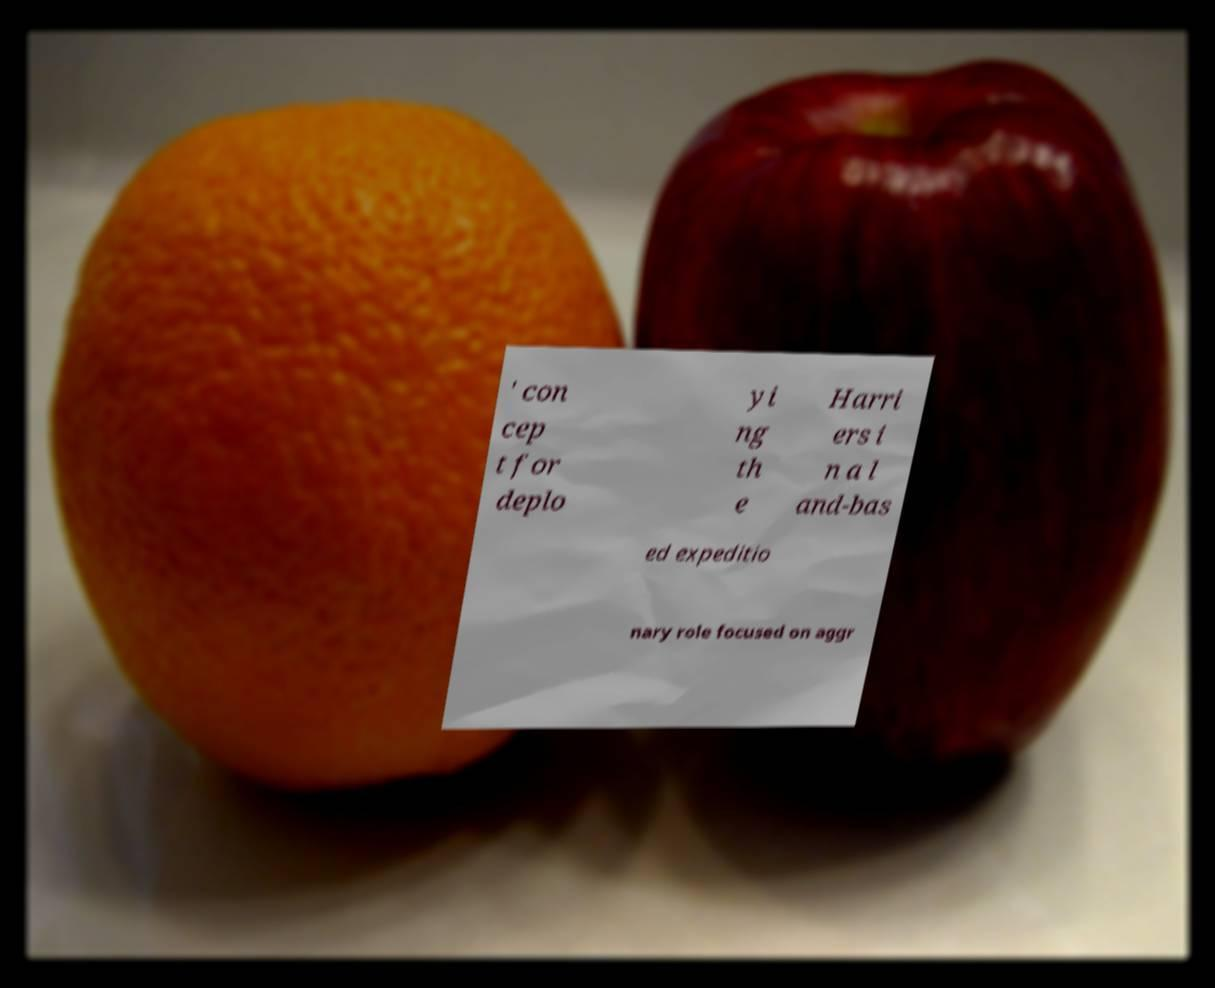Can you accurately transcribe the text from the provided image for me? ' con cep t for deplo yi ng th e Harri ers i n a l and-bas ed expeditio nary role focused on aggr 